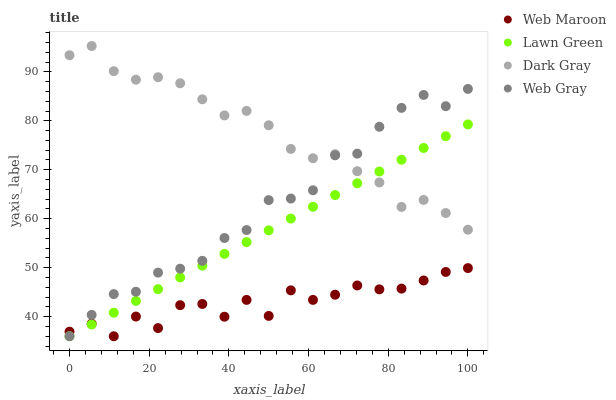Does Web Maroon have the minimum area under the curve?
Answer yes or no. Yes. Does Dark Gray have the maximum area under the curve?
Answer yes or no. Yes. Does Lawn Green have the minimum area under the curve?
Answer yes or no. No. Does Lawn Green have the maximum area under the curve?
Answer yes or no. No. Is Lawn Green the smoothest?
Answer yes or no. Yes. Is Web Maroon the roughest?
Answer yes or no. Yes. Is Web Gray the smoothest?
Answer yes or no. No. Is Web Gray the roughest?
Answer yes or no. No. Does Lawn Green have the lowest value?
Answer yes or no. Yes. Does Dark Gray have the highest value?
Answer yes or no. Yes. Does Lawn Green have the highest value?
Answer yes or no. No. Is Web Maroon less than Dark Gray?
Answer yes or no. Yes. Is Dark Gray greater than Web Maroon?
Answer yes or no. Yes. Does Lawn Green intersect Web Gray?
Answer yes or no. Yes. Is Lawn Green less than Web Gray?
Answer yes or no. No. Is Lawn Green greater than Web Gray?
Answer yes or no. No. Does Web Maroon intersect Dark Gray?
Answer yes or no. No. 